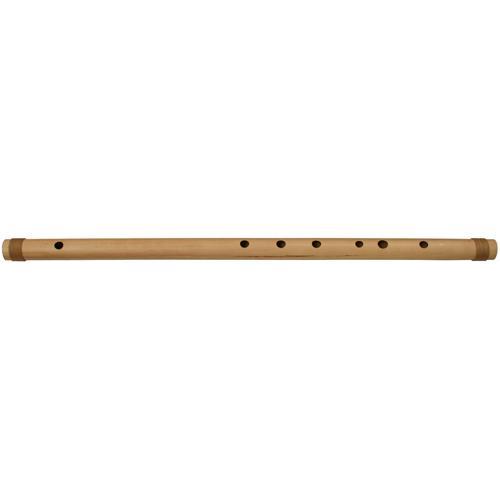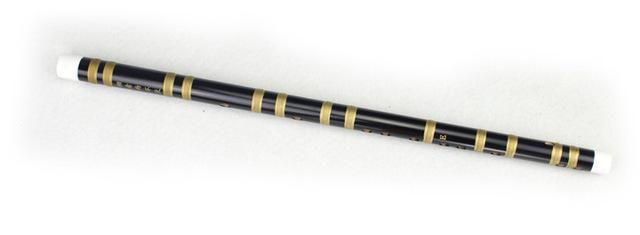The first image is the image on the left, the second image is the image on the right. Analyze the images presented: Is the assertion "Each image contains only one flute, which is displayed somewhat horizontally." valid? Answer yes or no. Yes. The first image is the image on the left, the second image is the image on the right. For the images displayed, is the sentence "In at least one image there is a brown wooden flute with only 7 drilled holes in it." factually correct? Answer yes or no. Yes. 